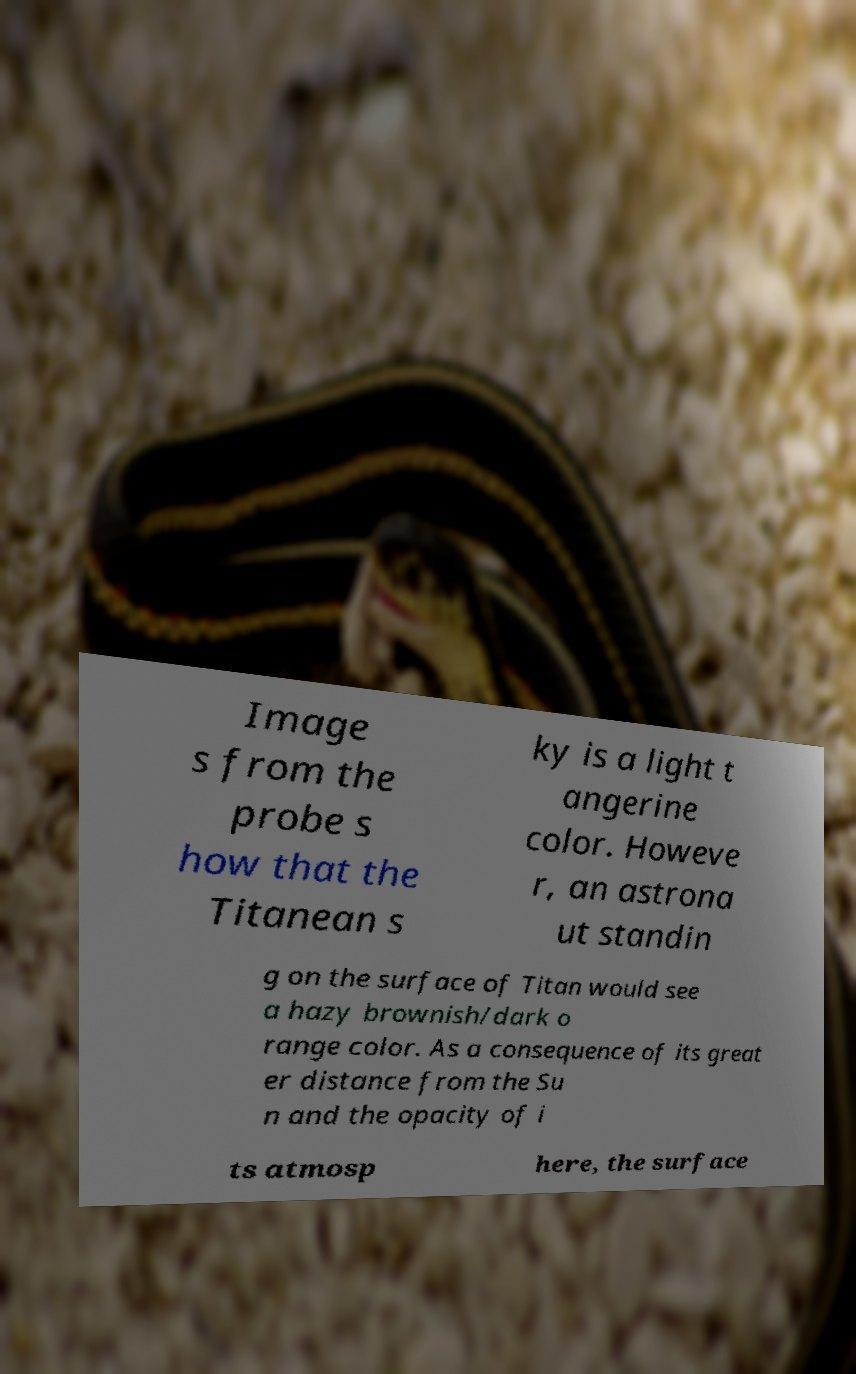Can you read and provide the text displayed in the image?This photo seems to have some interesting text. Can you extract and type it out for me? Image s from the probe s how that the Titanean s ky is a light t angerine color. Howeve r, an astrona ut standin g on the surface of Titan would see a hazy brownish/dark o range color. As a consequence of its great er distance from the Su n and the opacity of i ts atmosp here, the surface 